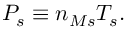Convert formula to latex. <formula><loc_0><loc_0><loc_500><loc_500>P _ { s } \equiv n _ { M s } T _ { s } .</formula> 